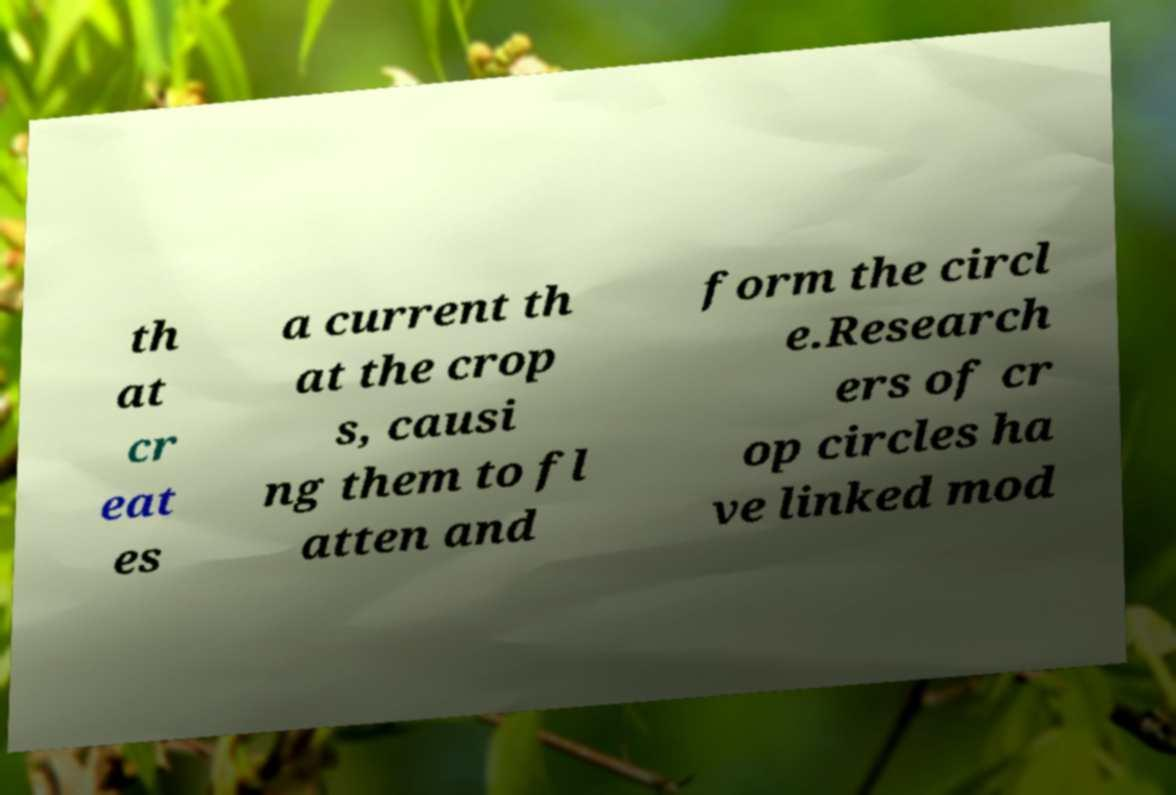There's text embedded in this image that I need extracted. Can you transcribe it verbatim? th at cr eat es a current th at the crop s, causi ng them to fl atten and form the circl e.Research ers of cr op circles ha ve linked mod 